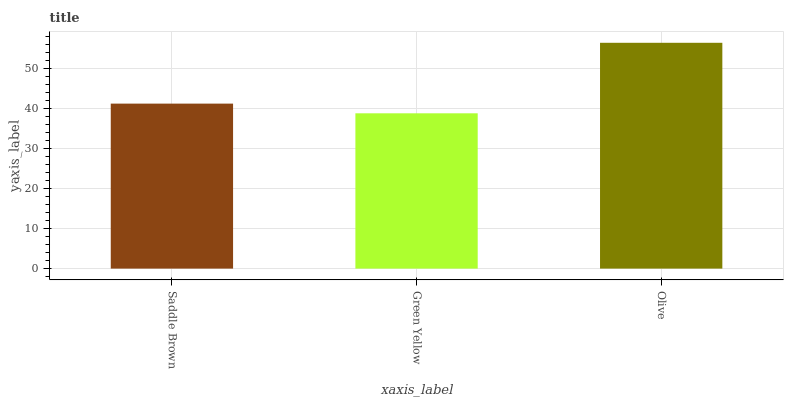Is Green Yellow the minimum?
Answer yes or no. Yes. Is Olive the maximum?
Answer yes or no. Yes. Is Olive the minimum?
Answer yes or no. No. Is Green Yellow the maximum?
Answer yes or no. No. Is Olive greater than Green Yellow?
Answer yes or no. Yes. Is Green Yellow less than Olive?
Answer yes or no. Yes. Is Green Yellow greater than Olive?
Answer yes or no. No. Is Olive less than Green Yellow?
Answer yes or no. No. Is Saddle Brown the high median?
Answer yes or no. Yes. Is Saddle Brown the low median?
Answer yes or no. Yes. Is Olive the high median?
Answer yes or no. No. Is Olive the low median?
Answer yes or no. No. 